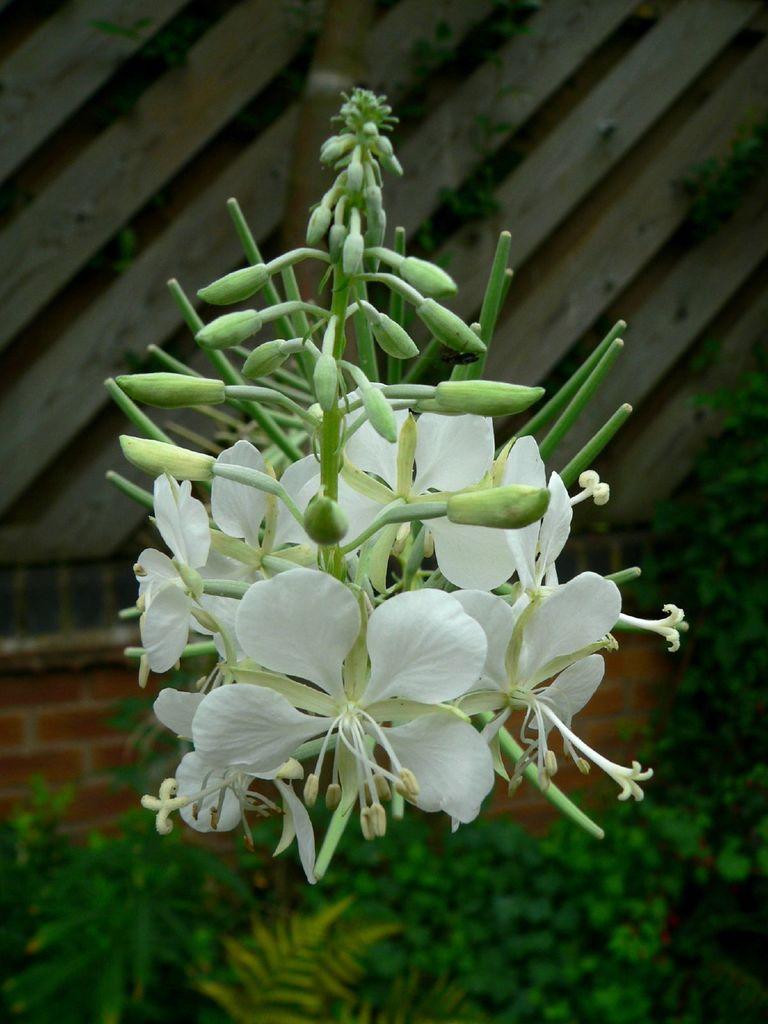How would you summarize this image in a sentence or two? In this image there is a pant to that plant there are flowers and buds, in the background there is a wooden wall. 